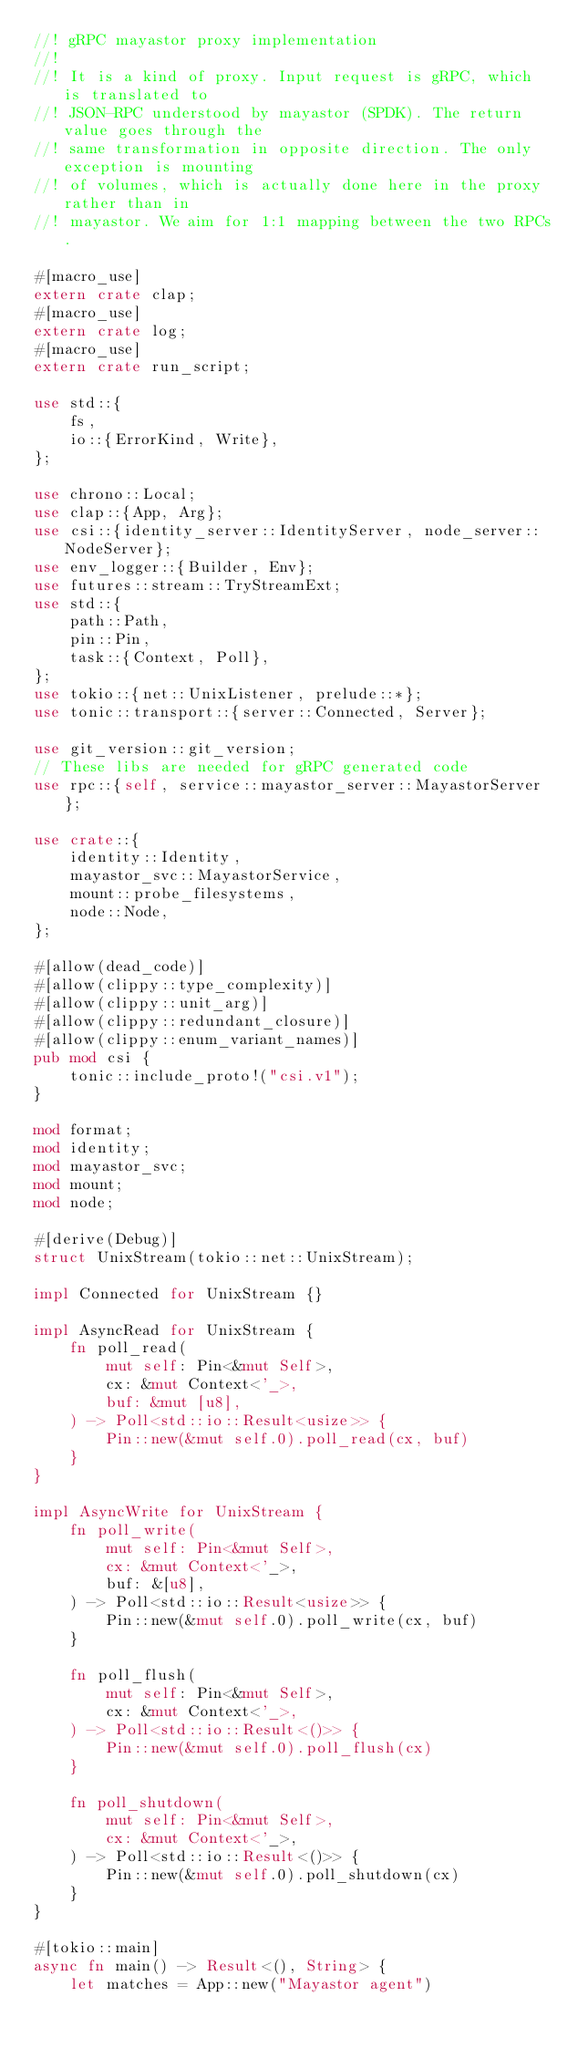<code> <loc_0><loc_0><loc_500><loc_500><_Rust_>//! gRPC mayastor proxy implementation
//!
//! It is a kind of proxy. Input request is gRPC, which is translated to
//! JSON-RPC understood by mayastor (SPDK). The return value goes through the
//! same transformation in opposite direction. The only exception is mounting
//! of volumes, which is actually done here in the proxy rather than in
//! mayastor. We aim for 1:1 mapping between the two RPCs.

#[macro_use]
extern crate clap;
#[macro_use]
extern crate log;
#[macro_use]
extern crate run_script;

use std::{
    fs,
    io::{ErrorKind, Write},
};

use chrono::Local;
use clap::{App, Arg};
use csi::{identity_server::IdentityServer, node_server::NodeServer};
use env_logger::{Builder, Env};
use futures::stream::TryStreamExt;
use std::{
    path::Path,
    pin::Pin,
    task::{Context, Poll},
};
use tokio::{net::UnixListener, prelude::*};
use tonic::transport::{server::Connected, Server};

use git_version::git_version;
// These libs are needed for gRPC generated code
use rpc::{self, service::mayastor_server::MayastorServer};

use crate::{
    identity::Identity,
    mayastor_svc::MayastorService,
    mount::probe_filesystems,
    node::Node,
};

#[allow(dead_code)]
#[allow(clippy::type_complexity)]
#[allow(clippy::unit_arg)]
#[allow(clippy::redundant_closure)]
#[allow(clippy::enum_variant_names)]
pub mod csi {
    tonic::include_proto!("csi.v1");
}

mod format;
mod identity;
mod mayastor_svc;
mod mount;
mod node;

#[derive(Debug)]
struct UnixStream(tokio::net::UnixStream);

impl Connected for UnixStream {}

impl AsyncRead for UnixStream {
    fn poll_read(
        mut self: Pin<&mut Self>,
        cx: &mut Context<'_>,
        buf: &mut [u8],
    ) -> Poll<std::io::Result<usize>> {
        Pin::new(&mut self.0).poll_read(cx, buf)
    }
}

impl AsyncWrite for UnixStream {
    fn poll_write(
        mut self: Pin<&mut Self>,
        cx: &mut Context<'_>,
        buf: &[u8],
    ) -> Poll<std::io::Result<usize>> {
        Pin::new(&mut self.0).poll_write(cx, buf)
    }

    fn poll_flush(
        mut self: Pin<&mut Self>,
        cx: &mut Context<'_>,
    ) -> Poll<std::io::Result<()>> {
        Pin::new(&mut self.0).poll_flush(cx)
    }

    fn poll_shutdown(
        mut self: Pin<&mut Self>,
        cx: &mut Context<'_>,
    ) -> Poll<std::io::Result<()>> {
        Pin::new(&mut self.0).poll_shutdown(cx)
    }
}

#[tokio::main]
async fn main() -> Result<(), String> {
    let matches = App::new("Mayastor agent")</code> 